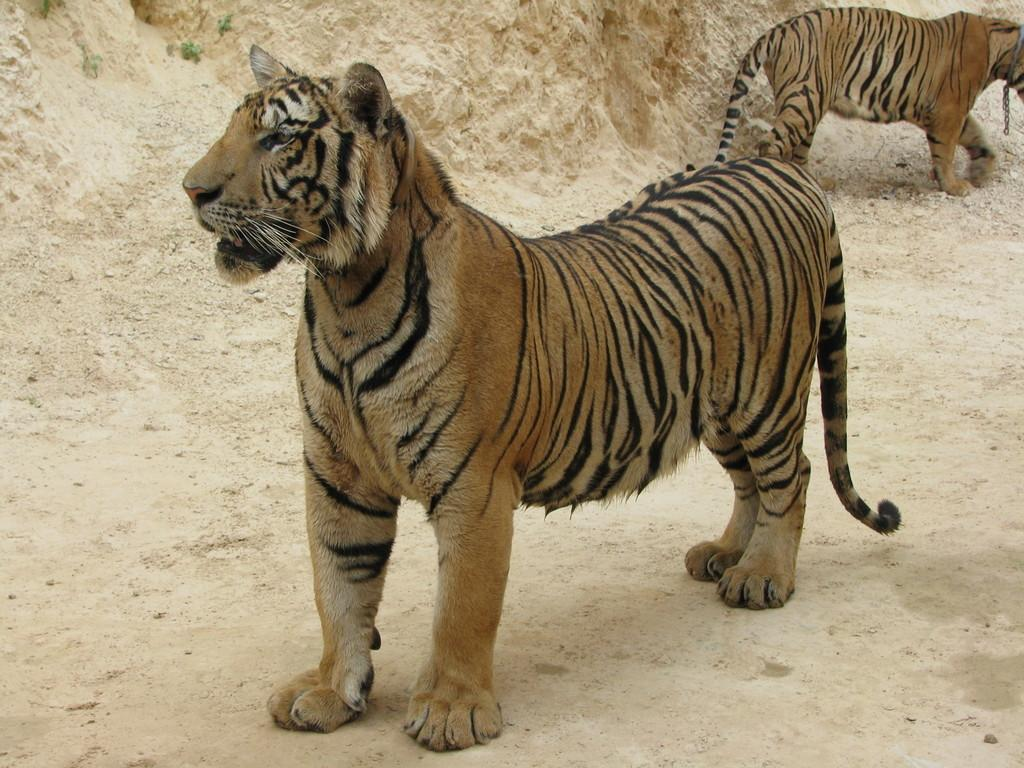How many tigers are present in the image? There are two tigers in the image. What colors can be seen on the tigers? The tigers are brown and black in color. What type of terrain is visible in the background of the image? The background of the image consists of rocks. What color are the rocks in the image? The rocks are in a cream color. What type of bat can be seen flying over the cemetery in the image? There is no bat or cemetery present in the image; it features two tigers and rocks in the background. Can you tell me how many hospital beds are visible in the image? There are no hospital beds present in the image. 